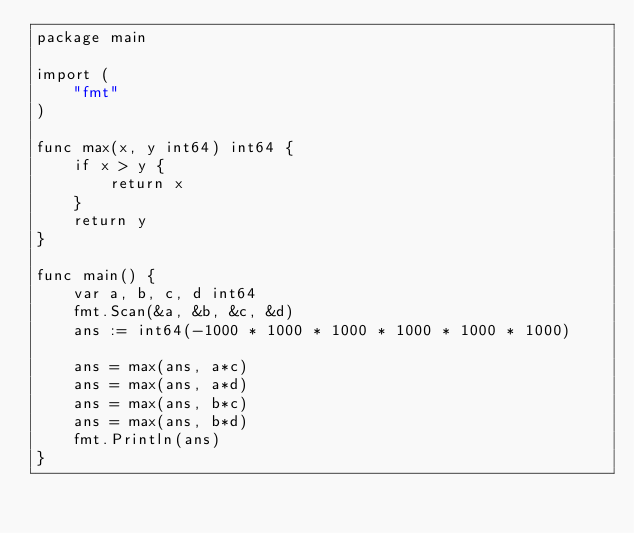Convert code to text. <code><loc_0><loc_0><loc_500><loc_500><_Go_>package main

import (
	"fmt"
)

func max(x, y int64) int64 {
	if x > y {
		return x
	}
	return y
}

func main() {
	var a, b, c, d int64
	fmt.Scan(&a, &b, &c, &d)
	ans := int64(-1000 * 1000 * 1000 * 1000 * 1000 * 1000)

	ans = max(ans, a*c)
	ans = max(ans, a*d)
	ans = max(ans, b*c)
	ans = max(ans, b*d)
	fmt.Println(ans)
}
</code> 